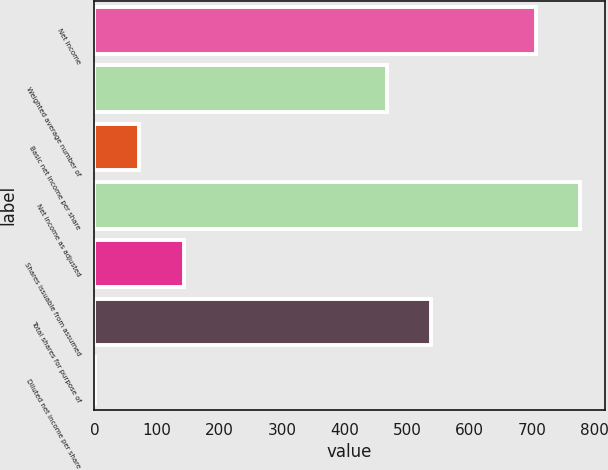<chart> <loc_0><loc_0><loc_500><loc_500><bar_chart><fcel>Net income<fcel>Weighted average number of<fcel>Basic net income per share<fcel>Net income as adjusted<fcel>Shares issuable from assumed<fcel>Total shares for purpose of<fcel>Diluted net income per share<nl><fcel>707<fcel>468<fcel>71.97<fcel>777.56<fcel>142.53<fcel>538.56<fcel>1.41<nl></chart> 